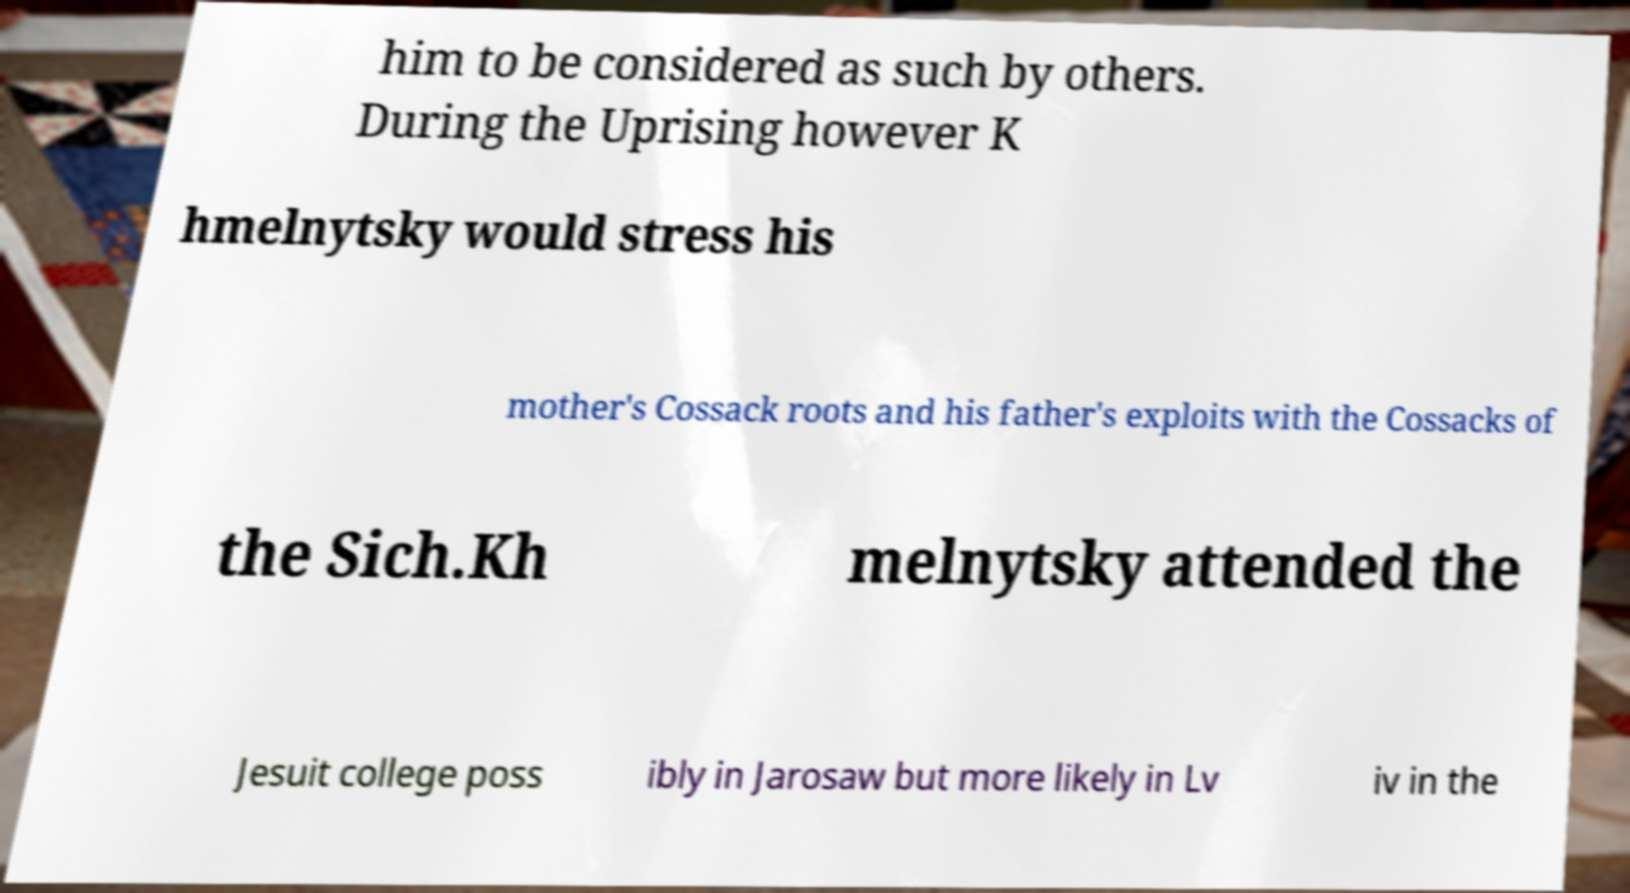Can you accurately transcribe the text from the provided image for me? him to be considered as such by others. During the Uprising however K hmelnytsky would stress his mother's Cossack roots and his father's exploits with the Cossacks of the Sich.Kh melnytsky attended the Jesuit college poss ibly in Jarosaw but more likely in Lv iv in the 